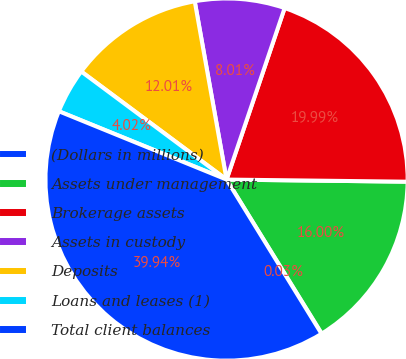Convert chart. <chart><loc_0><loc_0><loc_500><loc_500><pie_chart><fcel>(Dollars in millions)<fcel>Assets under management<fcel>Brokerage assets<fcel>Assets in custody<fcel>Deposits<fcel>Loans and leases (1)<fcel>Total client balances<nl><fcel>0.03%<fcel>16.0%<fcel>19.99%<fcel>8.01%<fcel>12.01%<fcel>4.02%<fcel>39.94%<nl></chart> 